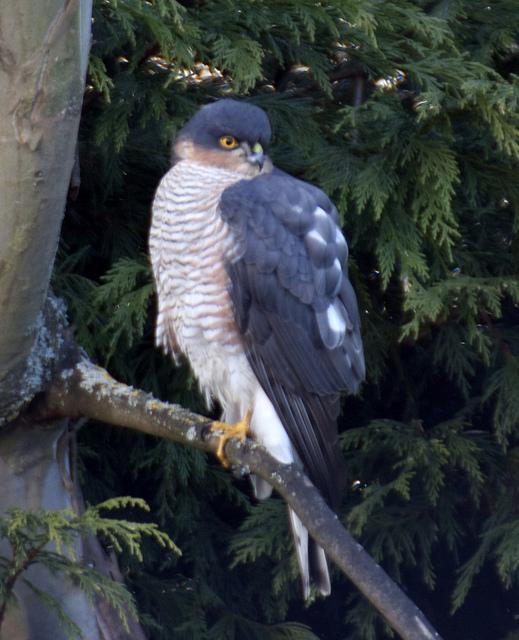What type of bird is this?
Give a very brief answer. Hawk. What color are the birds eyes?
Be succinct. Orange. What kind of bird is this?
Concise answer only. Hawk. What is the bird sitting on?
Answer briefly. Branch. 